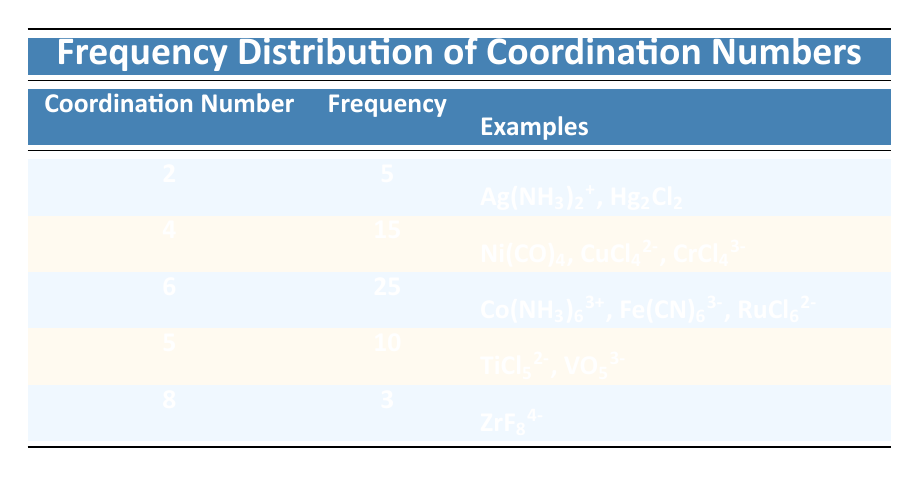What is the coordination number with the highest frequency? The coordination number with the highest frequency can be found by looking at the second column of the table. The highest frequency is 25, which corresponds to a coordination number of 6.
Answer: 6 How many coordination numbers have a frequency greater than 10? To determine this, count the frequencies in the table: the numbers 15 and 25 are greater than 10, corresponding to coordination numbers 4 and 6 respectively. Thus, there are 3 coordination numbers with a frequency greater than 10.
Answer: 3 What is the sum of the frequencies for coordination numbers 4 and 5? We add the frequencies of coordination numbers 4 and 5 from the table. The frequency for 4 is 15, and for 5, it is 10. Therefore, the sum is 15 + 10 = 25.
Answer: 25 Is there an example of a complex with a coordination number of 8? Looking at the examples section for coordination number 8 shows that there is indeed an entry: ZrF8^4-, which confirms that coordination number 8 is represented.
Answer: Yes How many total coordination numbers are represented in the table? The total number of coordination numbers can be calculated by counting the unique coordination numbers listed in the first column. There are 5 distinct coordination numbers: 2, 4, 6, 5, and 8.
Answer: 5 What is the average frequency of coordination numbers from the table? To find the average frequency, we first need to sum all the frequencies: 5 + 15 + 25 + 10 + 3 = 58. There are 5 data points, so the average is calculated as 58 divided by 5, which equals 11.6.
Answer: 11.6 Which coordination number has the lowest frequency? By examining the frequency values in the table, the lowest frequency is 3, which corresponds to the coordination number of 8.
Answer: 8 Are there any coordination numbers that have the same frequency? The frequencies are distinct for each coordination number listed: 5, 15, 25, 10, and 3, indicating that there are no matching frequencies.
Answer: No 